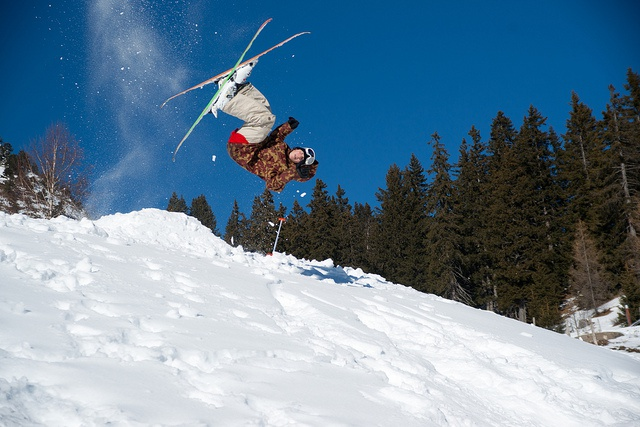Describe the objects in this image and their specific colors. I can see people in navy, black, maroon, lightgray, and darkgray tones and skis in navy, blue, gray, darkgray, and lightgray tones in this image. 